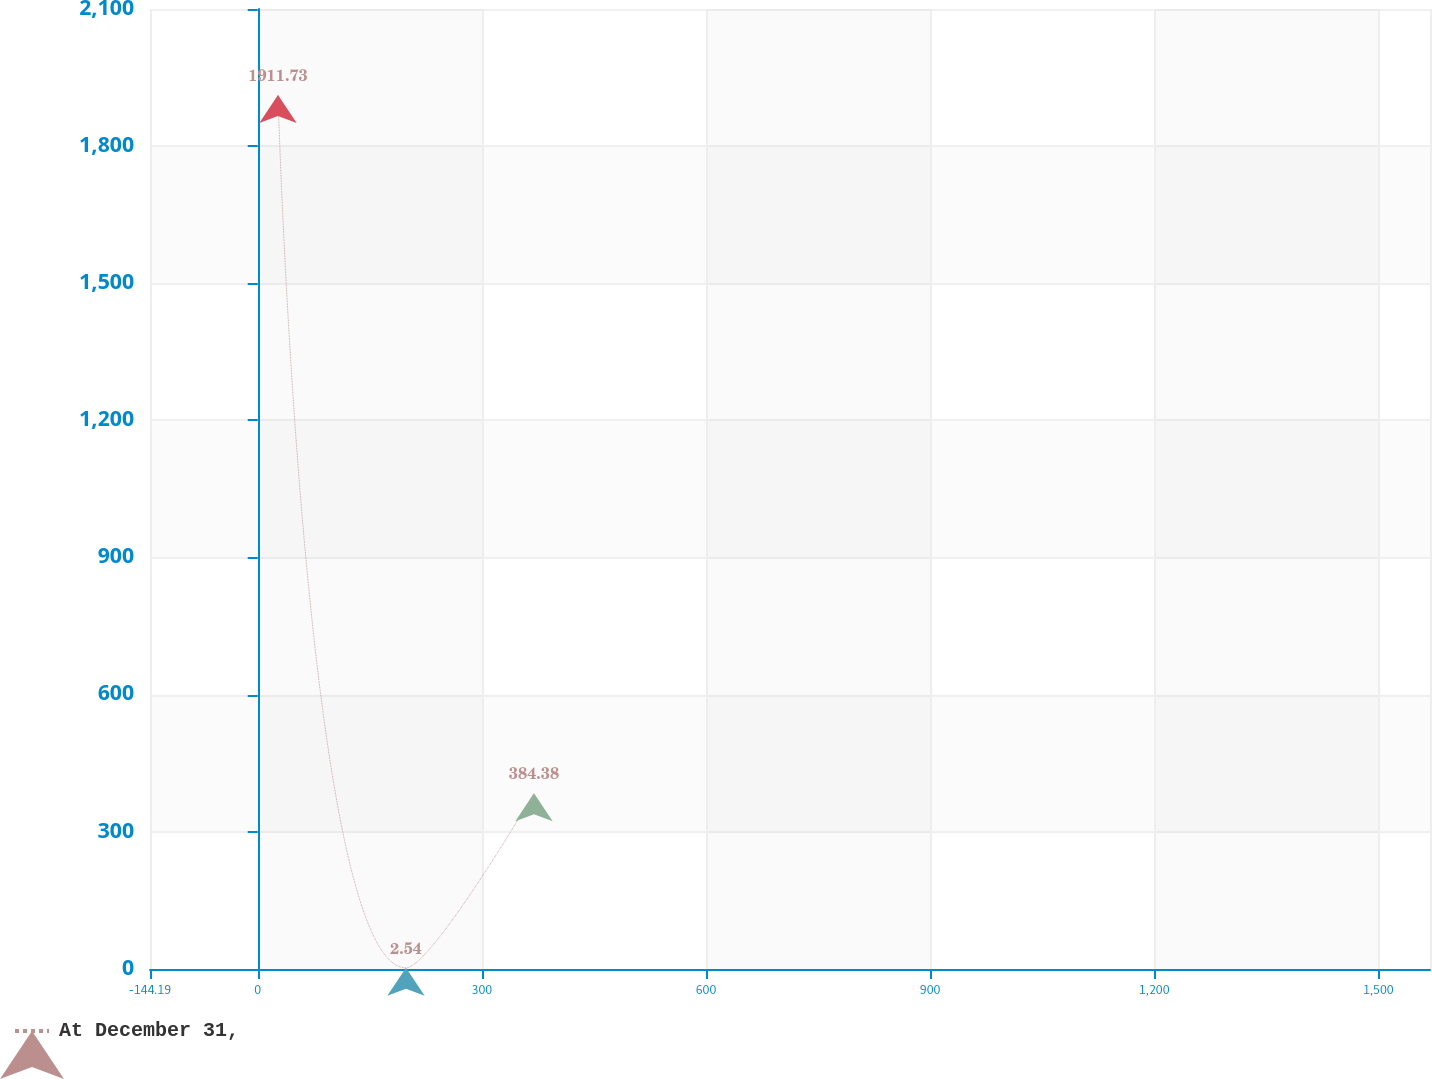Convert chart to OTSL. <chart><loc_0><loc_0><loc_500><loc_500><line_chart><ecel><fcel>At December 31,<nl><fcel>27.14<fcel>1911.73<nl><fcel>198.47<fcel>2.54<nl><fcel>369.8<fcel>384.38<nl><fcel>1740.44<fcel>193.46<nl></chart> 